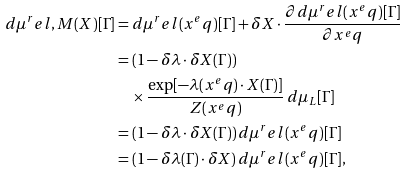Convert formula to latex. <formula><loc_0><loc_0><loc_500><loc_500>d \mu ^ { r } e l , M ( X ) [ \Gamma ] & = d \mu ^ { r } e l ( x ^ { e } q ) [ \Gamma ] + \delta X \cdot \frac { \partial d \mu ^ { r } e l ( x ^ { e } q ) [ \Gamma ] } { \partial x ^ { e } q } \\ & = ( 1 - \delta \lambda \cdot \delta X ( \Gamma ) ) \\ & \quad \times \frac { \exp [ - \lambda ( x ^ { e } q ) \cdot X ( \Gamma ) ] } { Z ( x ^ { e } q ) } \, d \mu _ { L } [ \Gamma ] \\ & = ( 1 - \delta \lambda \cdot \delta X ( \Gamma ) ) \, d \mu ^ { r } e l ( x ^ { e } q ) [ \Gamma ] \\ & = ( 1 - \delta \lambda ( \Gamma ) \cdot \delta X ) \, d \mu ^ { r } e l ( x ^ { e } q ) [ \Gamma ] ,</formula> 